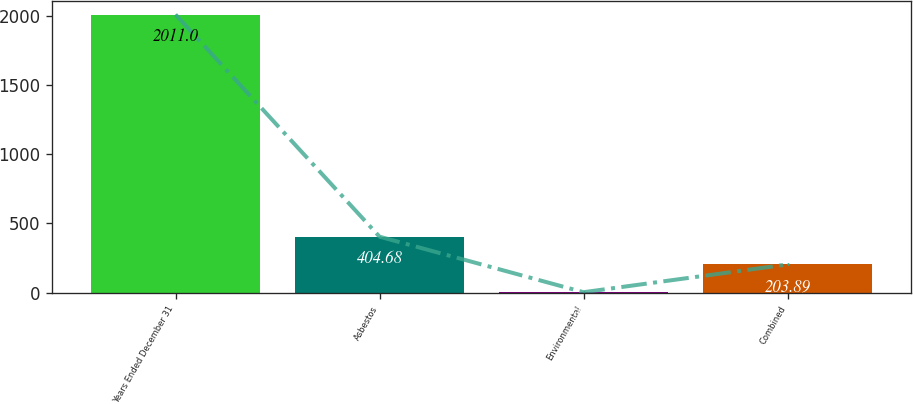Convert chart. <chart><loc_0><loc_0><loc_500><loc_500><bar_chart><fcel>Years Ended December 31<fcel>Asbestos<fcel>Environmental<fcel>Combined<nl><fcel>2011<fcel>404.68<fcel>3.1<fcel>203.89<nl></chart> 